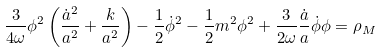Convert formula to latex. <formula><loc_0><loc_0><loc_500><loc_500>\frac { 3 } { 4 \omega } \phi ^ { 2 } \left ( \frac { \dot { a } ^ { 2 } } { a ^ { 2 } } + \frac { k } { a ^ { 2 } } \right ) - \frac { 1 } { 2 } \dot { \phi } ^ { 2 } - \frac { 1 } { 2 } m ^ { 2 } \phi ^ { 2 } + \frac { 3 } { 2 \omega } \frac { \dot { a } } { a } \dot { \phi } \phi = \rho _ { M }</formula> 